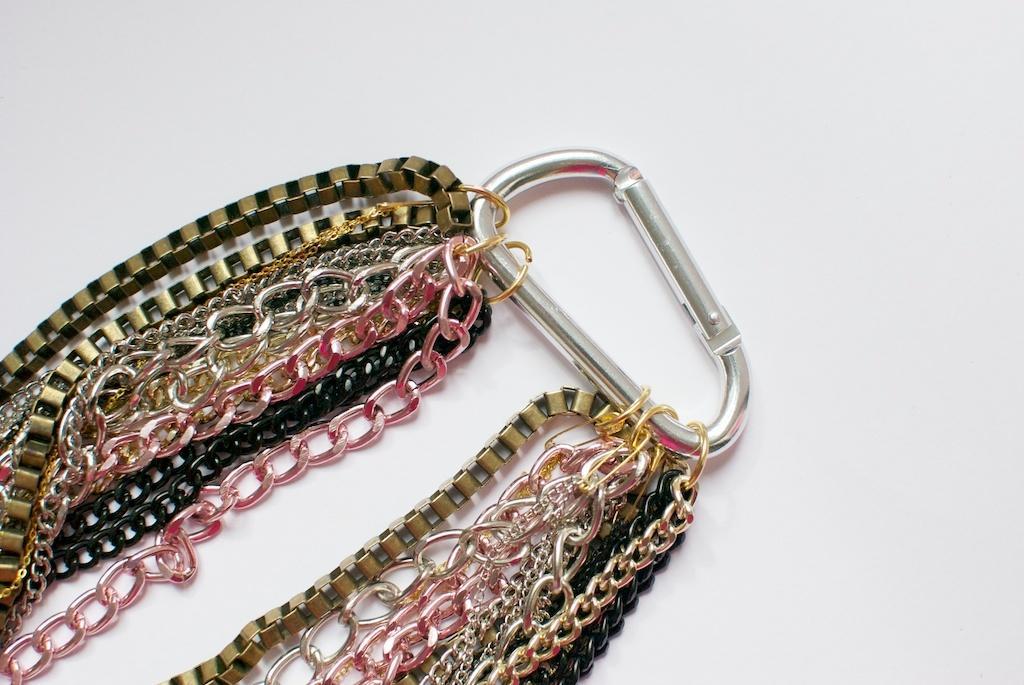Describe this image in one or two sentences. In this image, we can see a ring on the white background contains some chains. 